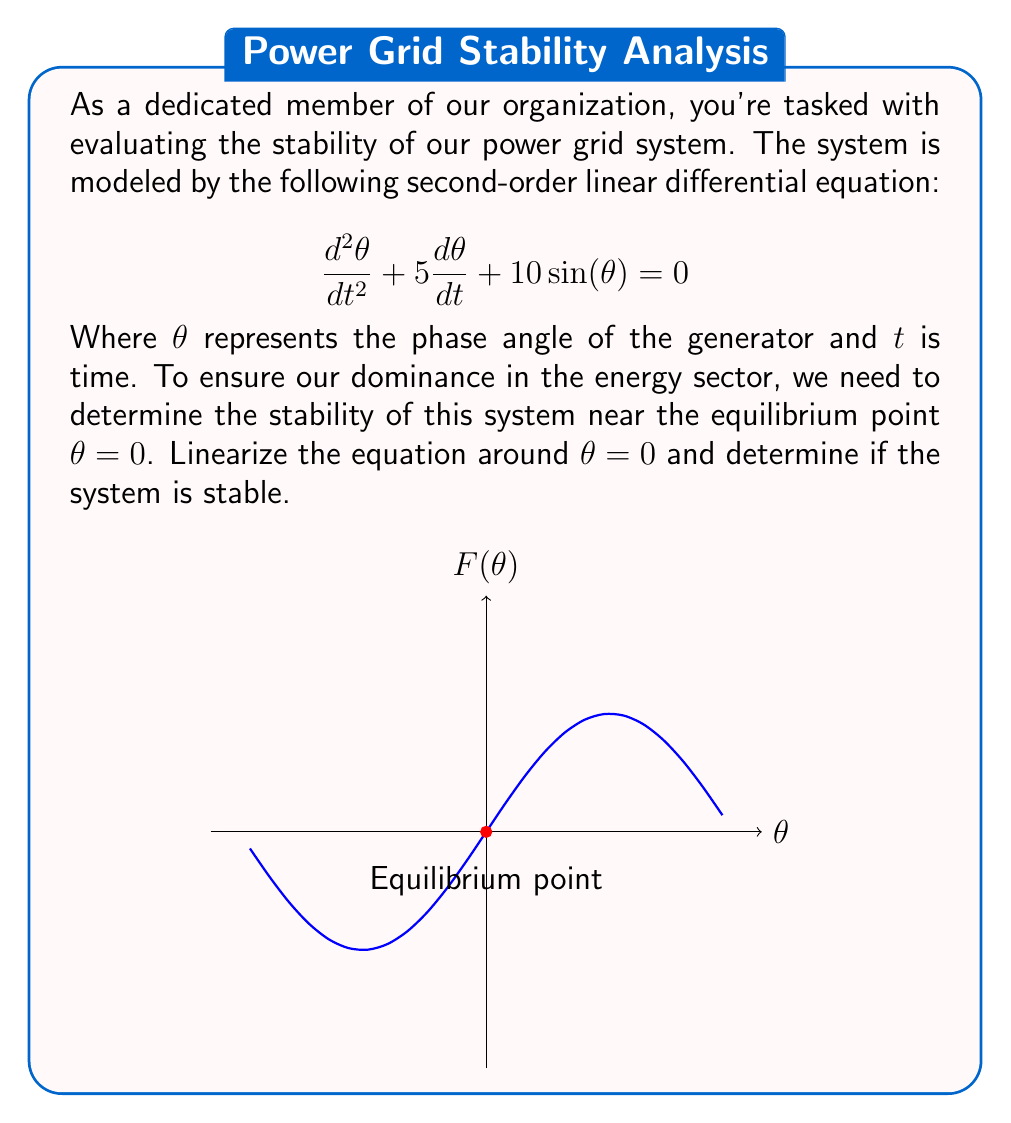What is the answer to this math problem? To evaluate the stability of the power grid system, we'll follow these steps:

1) First, we need to linearize the equation around $\theta = 0$. The nonlinear term is $\sin(\theta)$. We can use the small-angle approximation: $\sin(\theta) \approx \theta$ for small $\theta$.

2) Substituting this into our original equation:

   $$\frac{d^2\theta}{dt^2} + 5\frac{d\theta}{dt} + 10\theta = 0$$

3) This is now a linear second-order differential equation in the form:

   $$\frac{d^2\theta}{dt^2} + 2\zeta\omega_n\frac{d\theta}{dt} + \omega_n^2\theta = 0$$

   Where $\zeta$ is the damping ratio and $\omega_n$ is the natural frequency.

4) Comparing our linearized equation to this standard form, we can identify:

   $2\zeta\omega_n = 5$
   $\omega_n^2 = 10$

5) Solving for $\omega_n$:

   $\omega_n = \sqrt{10} \approx 3.16$

6) And then for $\zeta$:

   $\zeta = \frac{5}{2\sqrt{10}} \approx 0.79$

7) For a second-order system to be stable, we need $\zeta > 0$ and $\omega_n > 0$. Both conditions are satisfied here.

8) Furthermore, since $0 < \zeta < 1$, this system is underdamped, meaning it will approach equilibrium with decaying oscillations.

Therefore, the linearized system is stable around the equilibrium point $\theta = 0$.
Answer: Stable, underdamped system with $\zeta \approx 0.79$ and $\omega_n \approx 3.16$. 